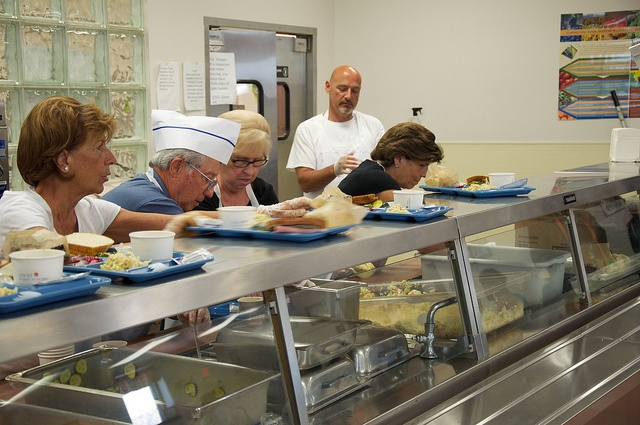Describe the objects in this image and their specific colors. I can see people in gray, maroon, black, and lightgray tones, people in gray, lightgray, and brown tones, people in gray, lightgray, maroon, and brown tones, people in gray, black, and maroon tones, and people in gray, brown, black, tan, and maroon tones in this image. 